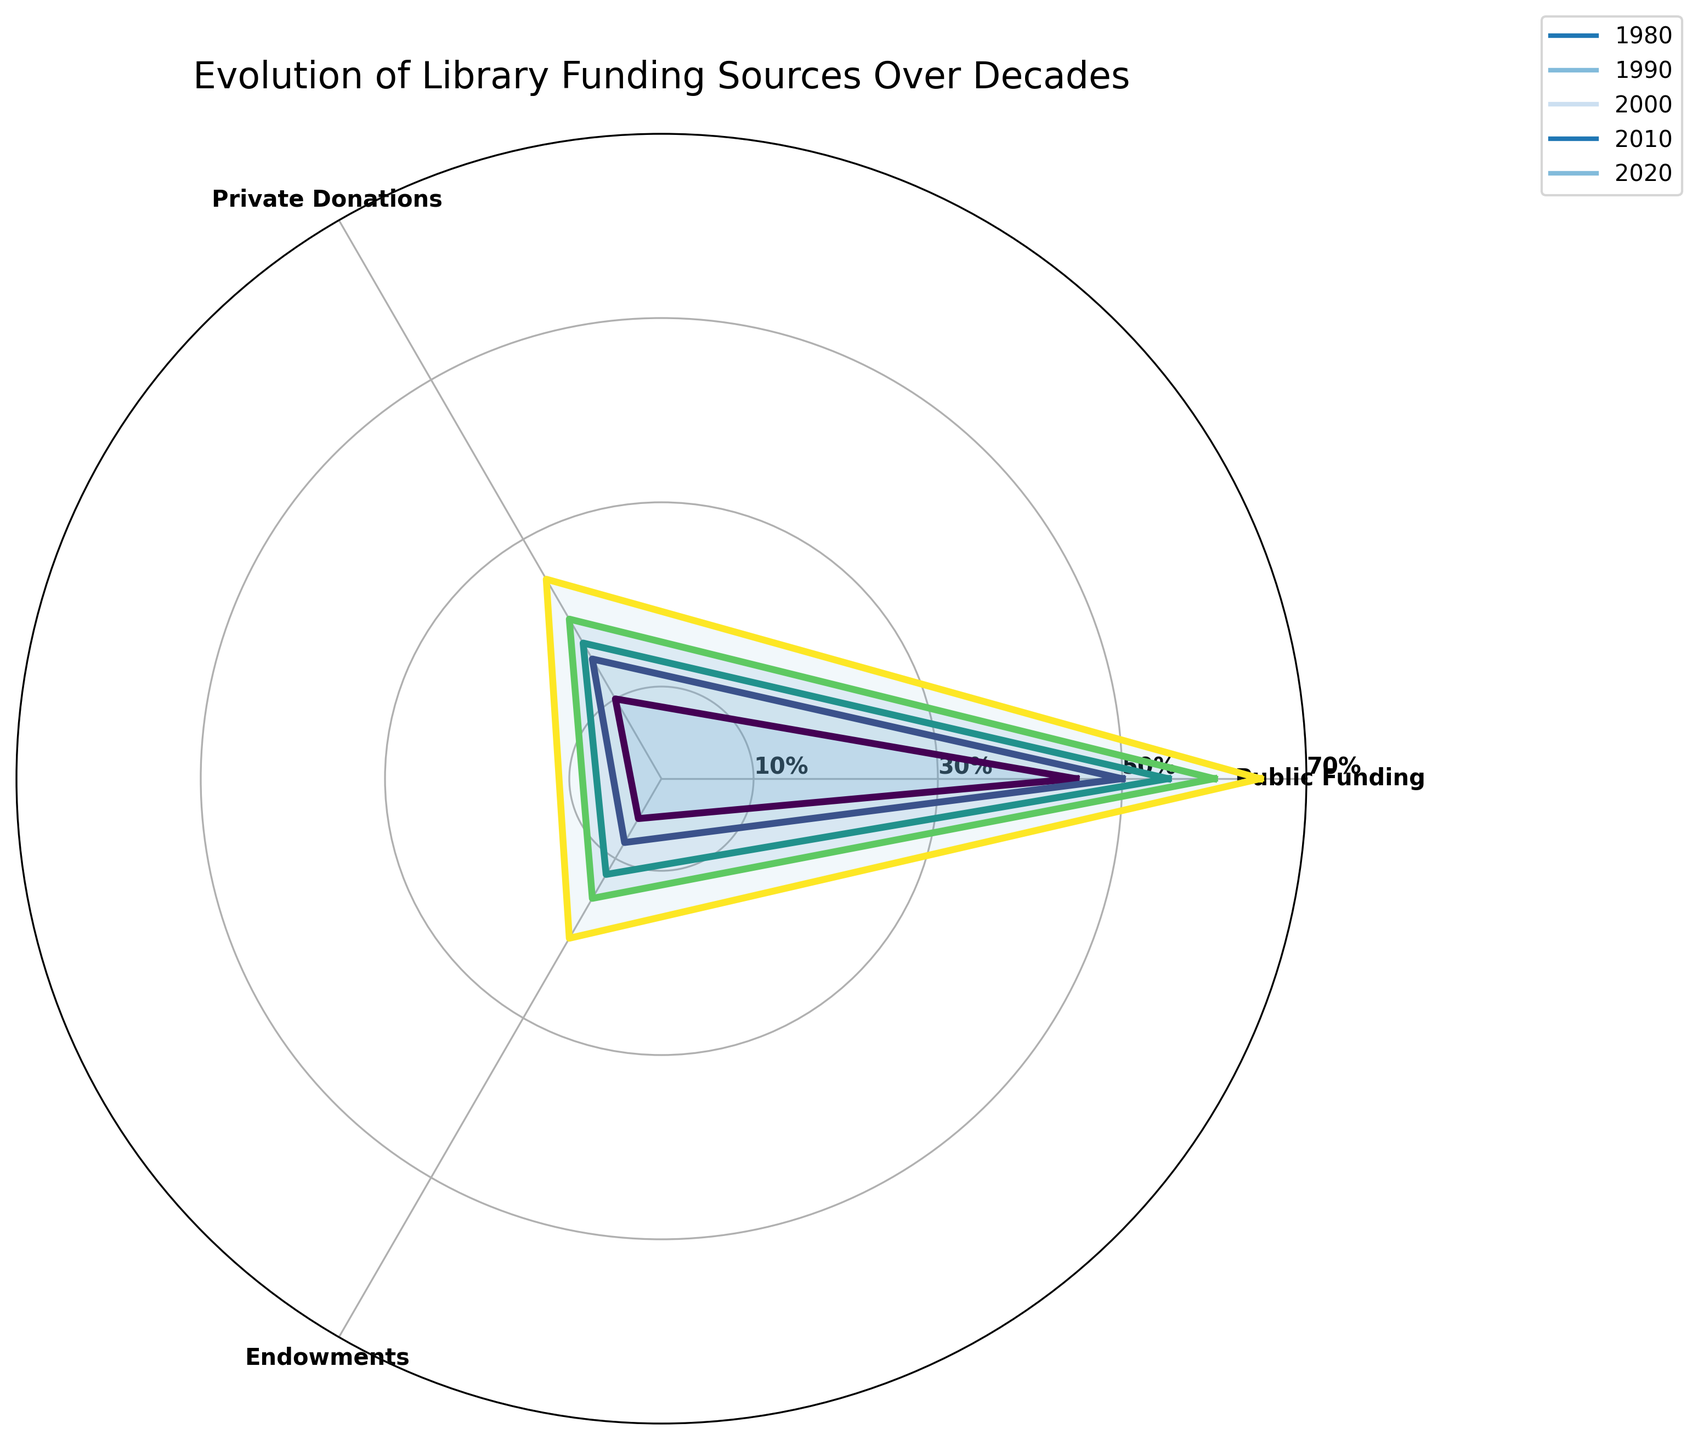What's the title of the radar chart? The title is usually placed at the top of the radar chart and summarizes what the chart is about.
Answer: Evolution of Library Funding Sources Over Decades Which category has the highest value in 2020? In 2020, the outermost line corresponding to the year is examined. Public Funding extends furthest, indicating it has the highest value in 2020.
Answer: Public Funding What is the range of the y-axis? The y-axis range is indicated by the rings extending outward from the center. It starts from 0 in the center and extends to 70 at the outermost ring.
Answer: 0 to 70 Between 1980 and 2020, which funding source saw the most considerable relative increase? By comparing the increase across decades for each funding source, Public Funding increased from 45% to 65% (+20%), Private Donations from 10% to 25% (+15%), and Endowments from 5% to 20% (+15%).
Answer: Public Funding In which decade did Private Donations first surpass 15%? Viewing the lines associated with Private Donations over time, it surpasses the 15% mark in the 2000 decade.
Answer: 2000 Compare Public Funding and Endowments in 1990. Which one is higher? In 1990, Public Funding is represented as 50%, while Endowments are shown as 8%. Therefore, Public Funding is higher.
Answer: Public Funding How many different funding sources are represented in the chart? The radar chart has three distinct axes radiating from the center, each representing a unique funding source category.
Answer: 3 What is the average value of Endowments over all decades shown? To find the average, sum the values 5, 8, 12, 15, and 20, which equals 60, then divide by 5 (the number of decades). This calculation yields 60/5=12.
Answer: 12 Which funding source showed the least growth between 1980 and 2020? Public Funding grew from 45% to 65% (+20%), Private Donations from 10% to 25% (+15%), and Endowments from 5% to 20% (+15%), so Private Donations and Endowments showed the least growth.
Answer: Private Donations and Endowments Is there any point where the funding sources were equal? By examining each decade, none of the lines intersect at the same radial distance for all three categories simultaneously, indicating that at no point were the funding sources equal.
Answer: No 